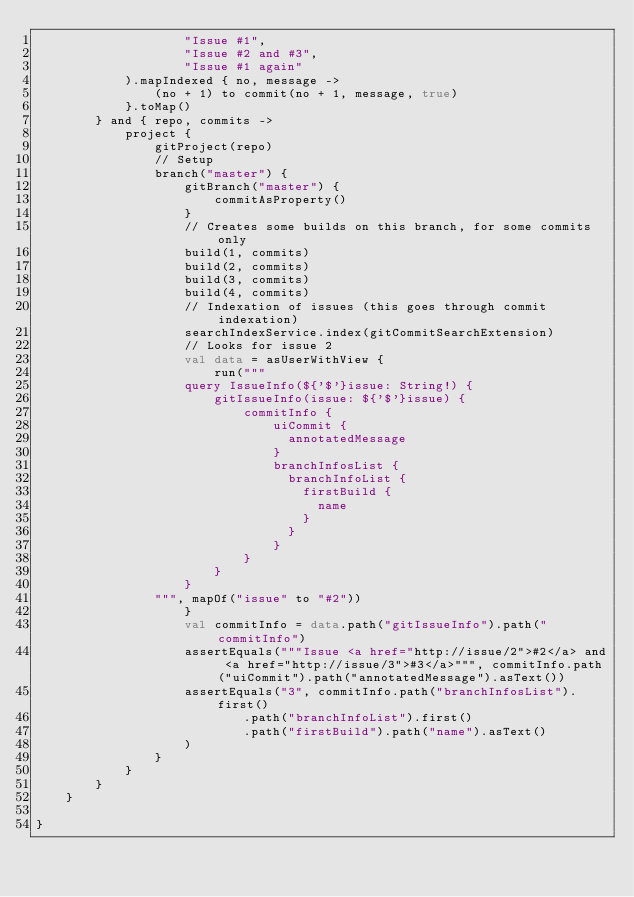Convert code to text. <code><loc_0><loc_0><loc_500><loc_500><_Kotlin_>                    "Issue #1",
                    "Issue #2 and #3",
                    "Issue #1 again"
            ).mapIndexed { no, message ->
                (no + 1) to commit(no + 1, message, true)
            }.toMap()
        } and { repo, commits ->
            project {
                gitProject(repo)
                // Setup
                branch("master") {
                    gitBranch("master") {
                        commitAsProperty()
                    }
                    // Creates some builds on this branch, for some commits only
                    build(1, commits)
                    build(2, commits)
                    build(3, commits)
                    build(4, commits)
                    // Indexation of issues (this goes through commit indexation)
                    searchIndexService.index(gitCommitSearchExtension)
                    // Looks for issue 2
                    val data = asUserWithView {
                        run("""
                    query IssueInfo(${'$'}issue: String!) {
                        gitIssueInfo(issue: ${'$'}issue) {
                            commitInfo {
                                uiCommit {
                                  annotatedMessage
                                }
                                branchInfosList {
                                  branchInfoList {
                                    firstBuild {
                                      name
                                    }
                                  }
                                }
                            }
                        }
                    }
                """, mapOf("issue" to "#2"))
                    }
                    val commitInfo = data.path("gitIssueInfo").path("commitInfo")
                    assertEquals("""Issue <a href="http://issue/2">#2</a> and <a href="http://issue/3">#3</a>""", commitInfo.path("uiCommit").path("annotatedMessage").asText())
                    assertEquals("3", commitInfo.path("branchInfosList").first()
                            .path("branchInfoList").first()
                            .path("firstBuild").path("name").asText()
                    )
                }
            }
        }
    }

}</code> 